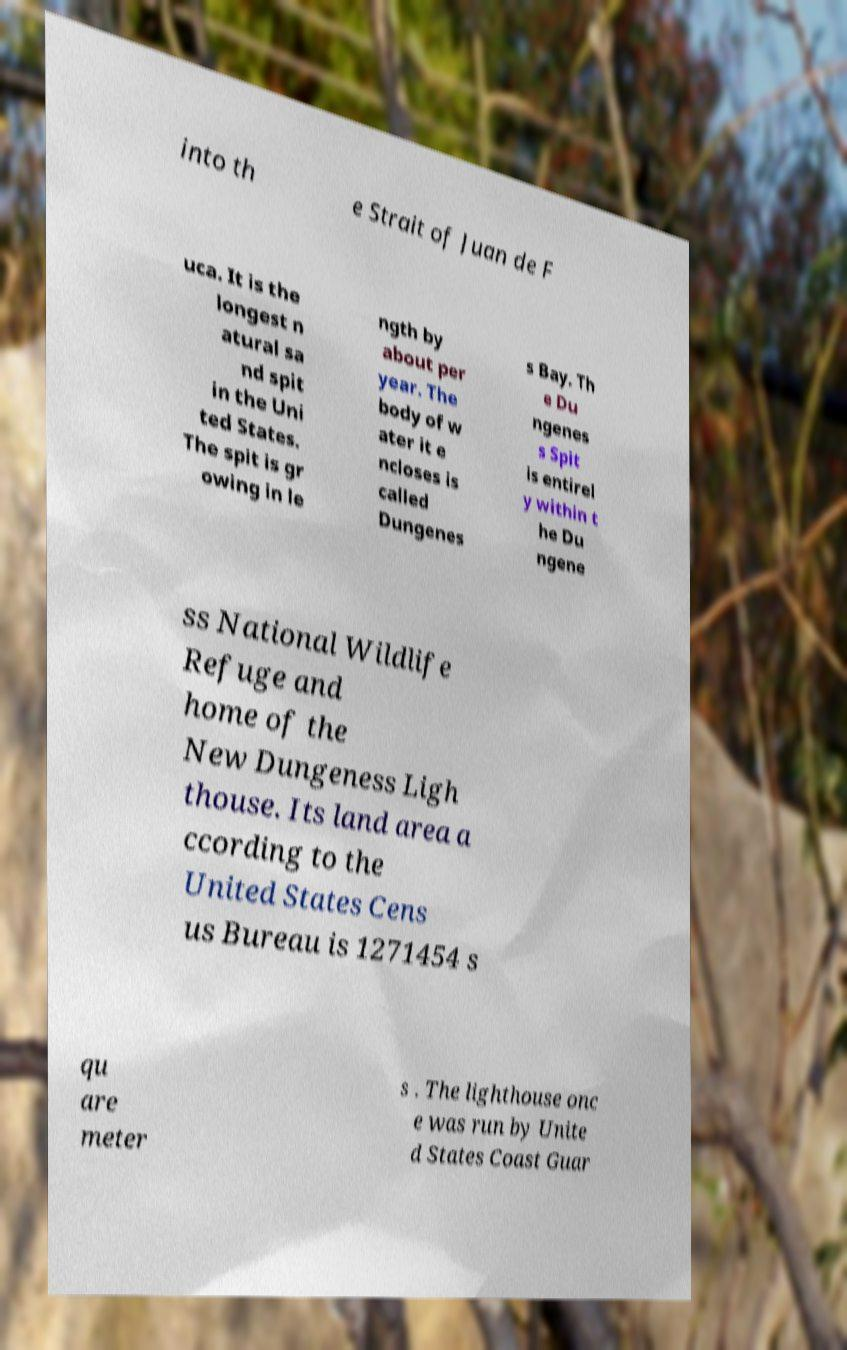Can you accurately transcribe the text from the provided image for me? into th e Strait of Juan de F uca. It is the longest n atural sa nd spit in the Uni ted States. The spit is gr owing in le ngth by about per year. The body of w ater it e ncloses is called Dungenes s Bay. Th e Du ngenes s Spit is entirel y within t he Du ngene ss National Wildlife Refuge and home of the New Dungeness Ligh thouse. Its land area a ccording to the United States Cens us Bureau is 1271454 s qu are meter s . The lighthouse onc e was run by Unite d States Coast Guar 